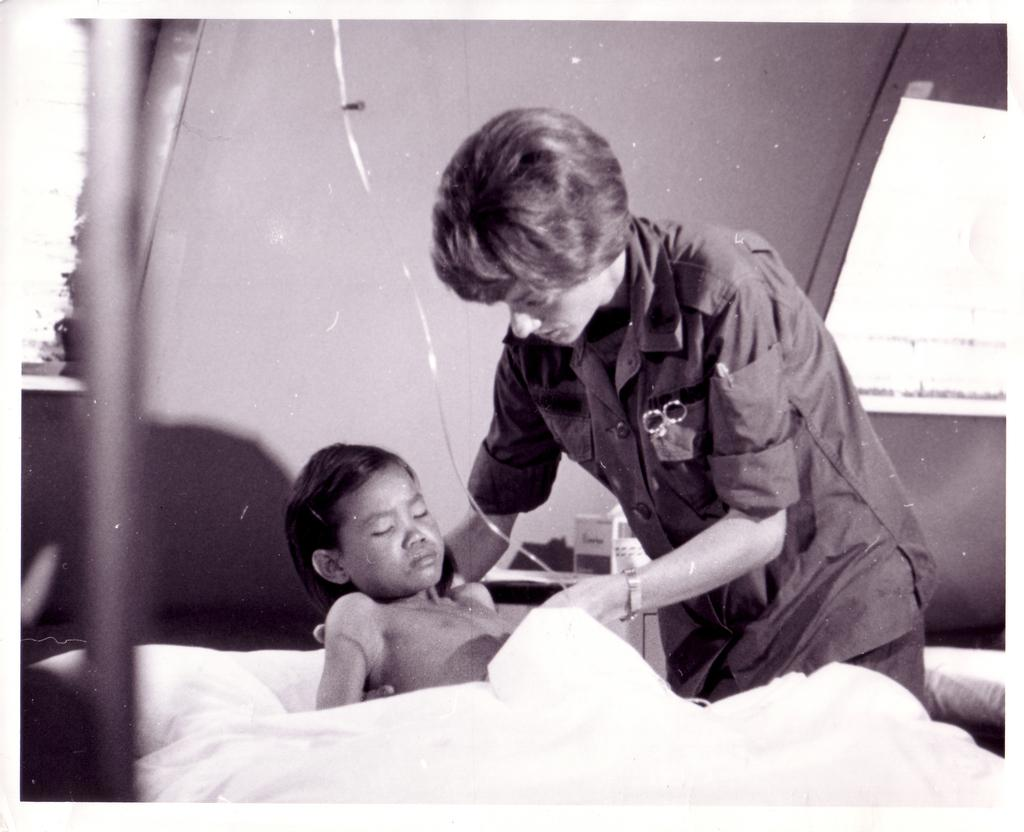What is the primary subject in the image? There is a woman standing in the image. What is the child doing in the image? The child is lying on a bed in the image. What is covering the child on the bed? The child has a bed sheet on them. What can be seen in the background of the image? There is a wall visible in the background of the image. What type of lip balm is the child using in the image? There is no lip balm present in the image; the child is lying on a bed with a bed sheet on them. 